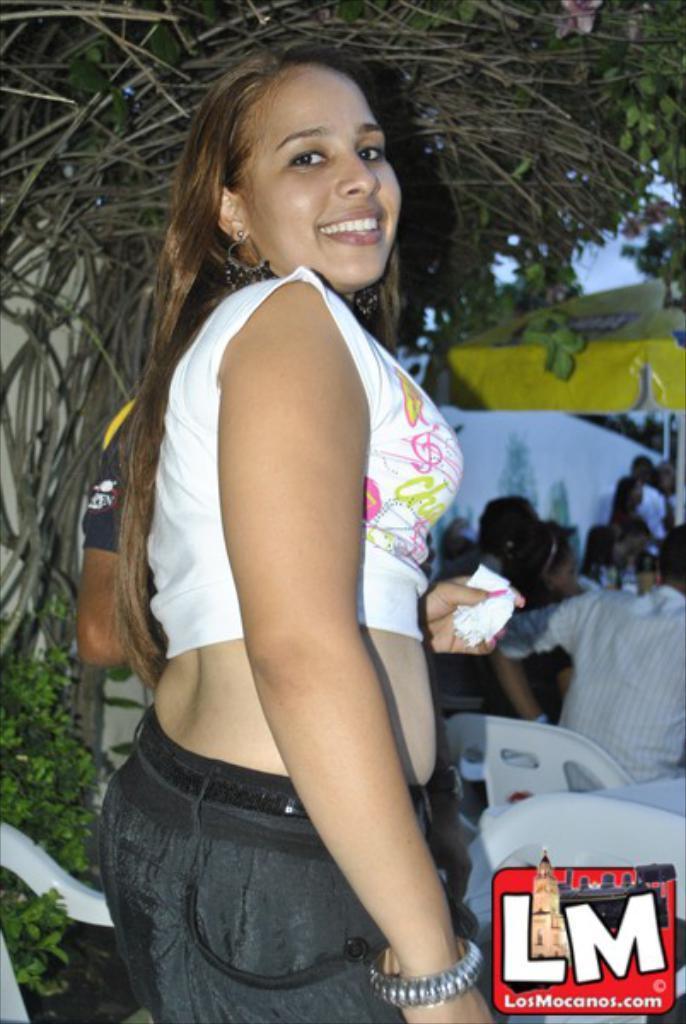Could you give a brief overview of what you see in this image? This image consists of a woman in the middle. She is smiling. There is a tree at the top. There are chairs at the bottom. There are some people sitting on chairs on the right side. 